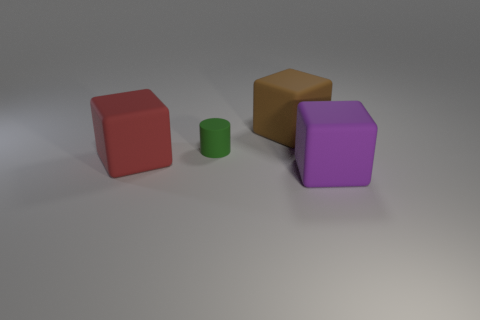There is a purple block right of the green cylinder; what number of things are left of it?
Your response must be concise. 3. Are there any other things that have the same shape as the green matte thing?
Provide a short and direct response. No. There is a matte thing on the right side of the large brown matte thing; is it the same color as the big thing that is to the left of the tiny green object?
Offer a very short reply. No. Are there fewer small blue balls than large purple rubber objects?
Your response must be concise. Yes. The thing that is in front of the cube left of the tiny green thing is what shape?
Provide a short and direct response. Cube. Are there any other things that have the same size as the green rubber thing?
Offer a terse response. No. There is a thing that is on the left side of the small green rubber cylinder left of the big cube that is behind the large red rubber object; what shape is it?
Your answer should be very brief. Cube. What number of objects are rubber things that are right of the small green thing or things that are to the left of the big brown thing?
Provide a short and direct response. 4. Do the rubber cylinder and the matte cube that is to the left of the large brown block have the same size?
Your response must be concise. No. Are the large cube that is in front of the red matte block and the large brown object that is on the right side of the red thing made of the same material?
Your response must be concise. Yes. 